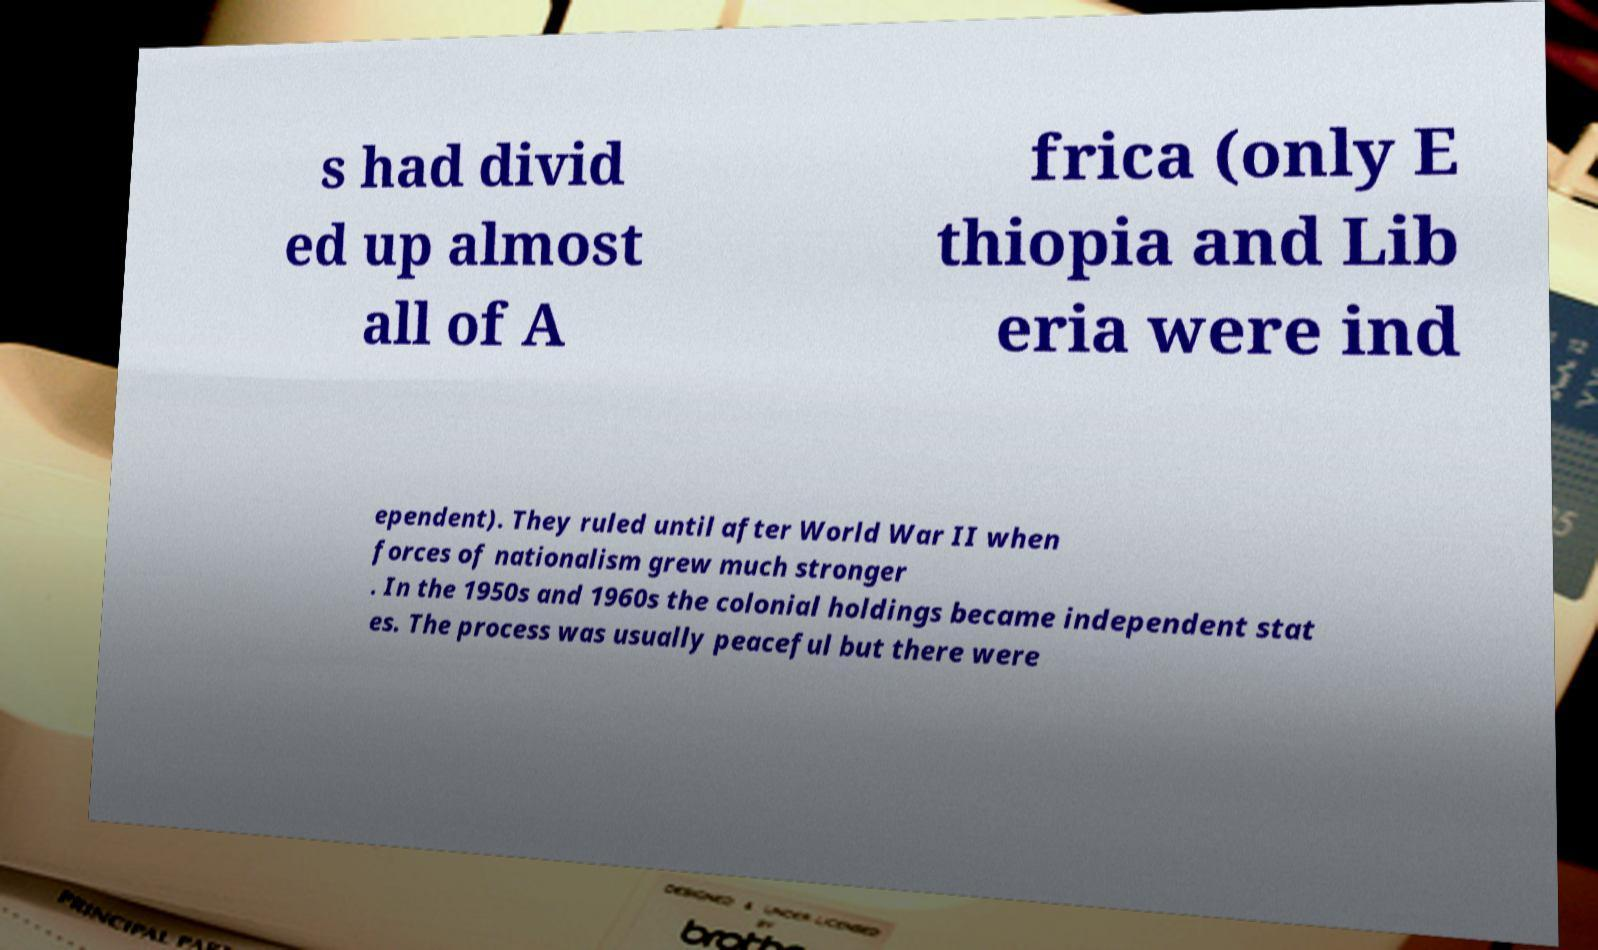Please identify and transcribe the text found in this image. s had divid ed up almost all of A frica (only E thiopia and Lib eria were ind ependent). They ruled until after World War II when forces of nationalism grew much stronger . In the 1950s and 1960s the colonial holdings became independent stat es. The process was usually peaceful but there were 